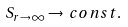Convert formula to latex. <formula><loc_0><loc_0><loc_500><loc_500>S _ { r \rightarrow \infty } \rightarrow \, c o n s t .</formula> 